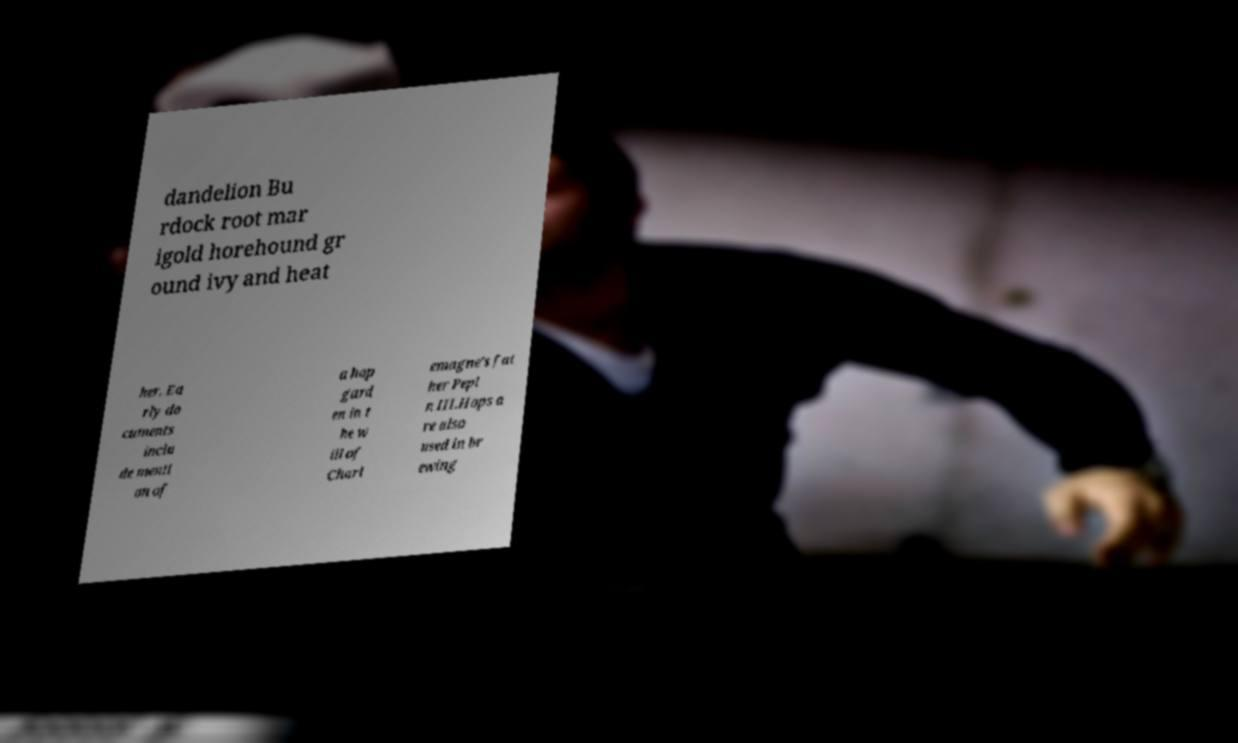Can you accurately transcribe the text from the provided image for me? dandelion Bu rdock root mar igold horehound gr ound ivy and heat her. Ea rly do cuments inclu de menti on of a hop gard en in t he w ill of Charl emagne's fat her Pepi n III.Hops a re also used in br ewing 